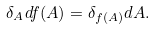<formula> <loc_0><loc_0><loc_500><loc_500>\delta _ { A } d f ( A ) = \delta _ { f ( A ) } d A .</formula> 